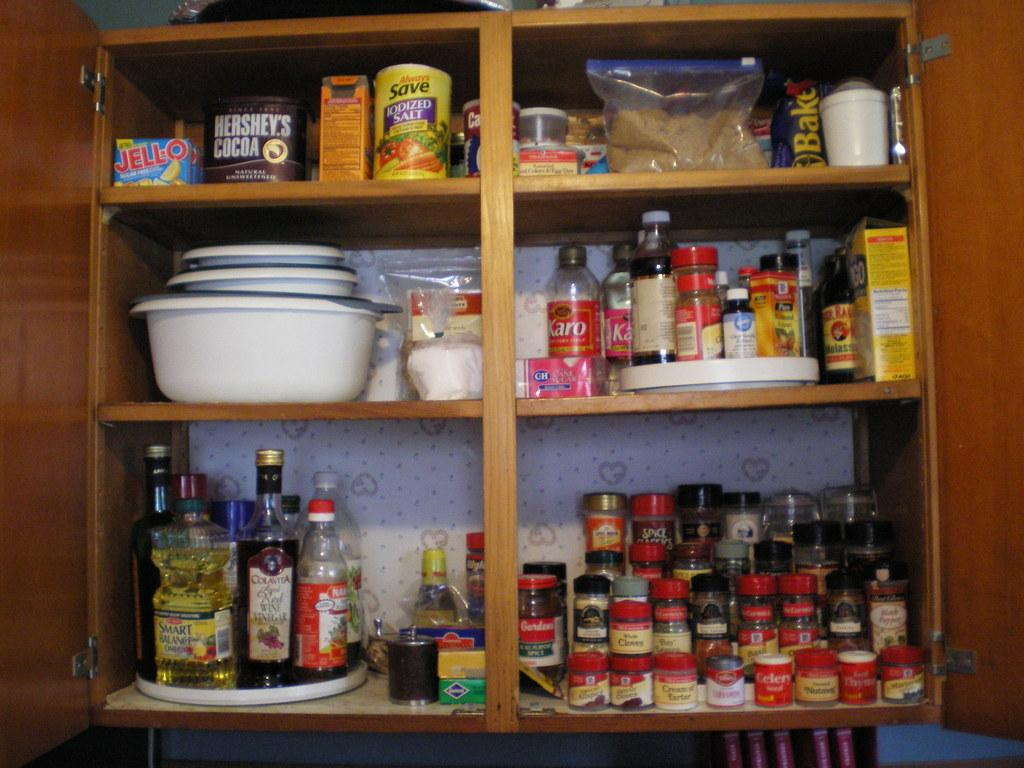What type of furniture is visible in the image? There is a cupboard in the image. What is inside the cupboard? The cupboard is filled with bottles, containers, boxes, and bowls, as well as other food items. How does the digestion process of the blood in the crate affect the food items in the cupboard? There is no crate, digestion, or blood present in the image. The image only shows a cupboard filled with bottles, containers, boxes, bowls, and other food items. 